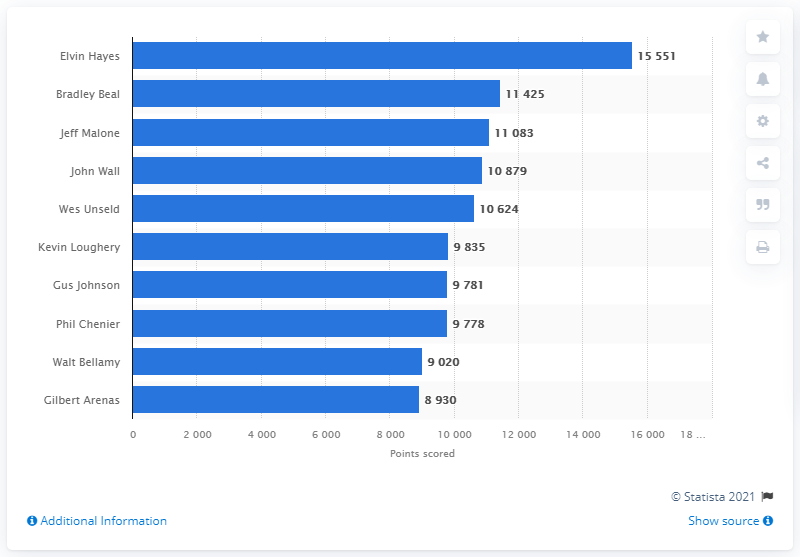Draw attention to some important aspects in this diagram. The career points leader of the Washington Wizards is Elvin Hayes. 